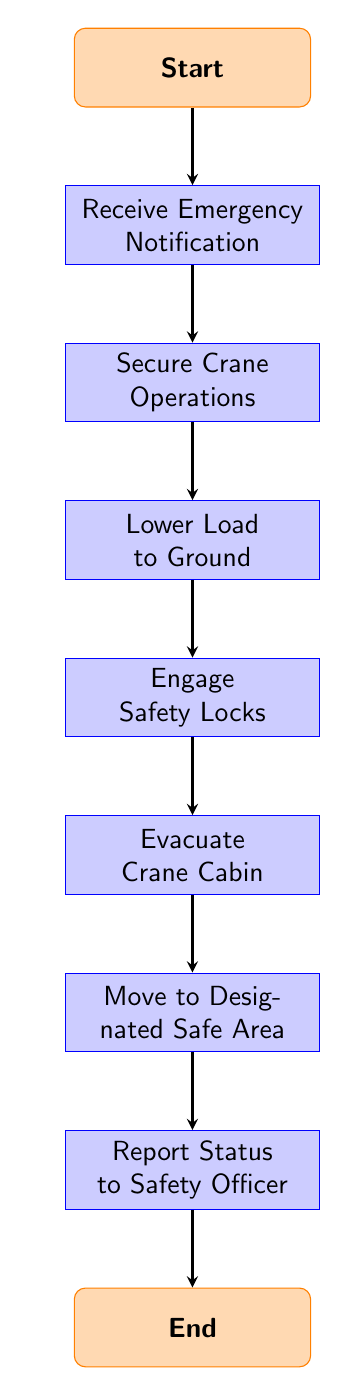What is the first action taken after receiving an emergency notification? The first action after receiving an emergency notification, as indicated by the arrow leading from the 'Receive Emergency Notification' node, is to 'Secure Crane Operations.'
Answer: Secure Crane Operations How many nodes are there in the diagram? To find the number of nodes, count each section: Start, Receive Emergency Notification, Secure Crane Operations, Lower Load to Ground, Engage Safety Locks, Evacuate Crane Cabin, Move to Designated Safe Area, Report Status to Safety Officer, and End. This totals to 9 nodes.
Answer: 9 What action must be taken before evacuating the crane cabin? According to the flow of the diagram, 'Engage Safety Locks' must be completed before moving on to 'Evacuate Crane Cabin.' This is a necessary step in the evacuation process.
Answer: Engage Safety Locks Which step follows after moving to the designated safe area? After moving to the 'Designated Safe Area,' the next step, as indicated in the diagram, is to 'Report Status to Safety Officer.' This shows the order of actions concerning emergency protocol.
Answer: Report Status to Safety Officer What is the last action in the evacuation procedure? The final action in the evacuation procedure, indicated by the last node before reaching 'End,' is to 'Report Status to Safety Officer.' This underscores the importance of communication after an emergency.
Answer: Report Status to Safety Officer What happens immediately after securing crane operations? Immediately after securing crane operations, the next step is to 'Lower Load to Ground,' as denoted by the direct arrow connecting these two nodes.
Answer: Lower Load to Ground Are there any decision points in this diagram? This flow chart does not contain any decision nodes; it consists only of process steps and a linear flow from start to end without any branches or choices.
Answer: No 